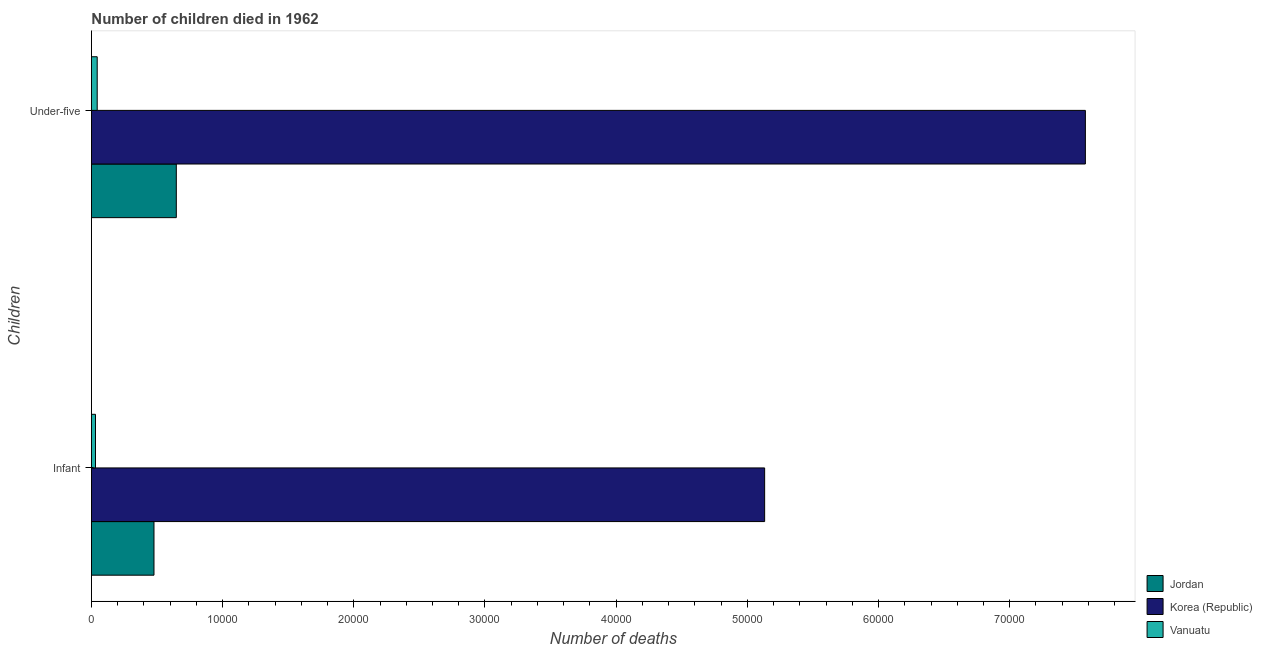Are the number of bars on each tick of the Y-axis equal?
Your answer should be very brief. Yes. How many bars are there on the 1st tick from the top?
Your response must be concise. 3. How many bars are there on the 2nd tick from the bottom?
Your answer should be very brief. 3. What is the label of the 2nd group of bars from the top?
Provide a succinct answer. Infant. What is the number of under-five deaths in Vanuatu?
Provide a succinct answer. 441. Across all countries, what is the maximum number of under-five deaths?
Give a very brief answer. 7.58e+04. Across all countries, what is the minimum number of infant deaths?
Provide a short and direct response. 311. In which country was the number of infant deaths minimum?
Keep it short and to the point. Vanuatu. What is the total number of infant deaths in the graph?
Provide a short and direct response. 5.64e+04. What is the difference between the number of infant deaths in Vanuatu and that in Korea (Republic)?
Give a very brief answer. -5.10e+04. What is the difference between the number of under-five deaths in Jordan and the number of infant deaths in Vanuatu?
Your response must be concise. 6160. What is the average number of infant deaths per country?
Make the answer very short. 1.88e+04. What is the difference between the number of infant deaths and number of under-five deaths in Jordan?
Provide a short and direct response. -1702. In how many countries, is the number of infant deaths greater than 68000 ?
Keep it short and to the point. 0. What is the ratio of the number of infant deaths in Jordan to that in Korea (Republic)?
Make the answer very short. 0.09. What does the 1st bar from the top in Under-five represents?
Keep it short and to the point. Vanuatu. What does the 1st bar from the bottom in Infant represents?
Provide a short and direct response. Jordan. Are all the bars in the graph horizontal?
Provide a succinct answer. Yes. Are the values on the major ticks of X-axis written in scientific E-notation?
Your answer should be compact. No. Does the graph contain any zero values?
Provide a succinct answer. No. Does the graph contain grids?
Your answer should be compact. No. Where does the legend appear in the graph?
Provide a succinct answer. Bottom right. How are the legend labels stacked?
Offer a very short reply. Vertical. What is the title of the graph?
Offer a terse response. Number of children died in 1962. What is the label or title of the X-axis?
Offer a very short reply. Number of deaths. What is the label or title of the Y-axis?
Provide a succinct answer. Children. What is the Number of deaths in Jordan in Infant?
Provide a short and direct response. 4769. What is the Number of deaths of Korea (Republic) in Infant?
Provide a short and direct response. 5.13e+04. What is the Number of deaths of Vanuatu in Infant?
Ensure brevity in your answer.  311. What is the Number of deaths in Jordan in Under-five?
Ensure brevity in your answer.  6471. What is the Number of deaths in Korea (Republic) in Under-five?
Your answer should be compact. 7.58e+04. What is the Number of deaths in Vanuatu in Under-five?
Give a very brief answer. 441. Across all Children, what is the maximum Number of deaths in Jordan?
Ensure brevity in your answer.  6471. Across all Children, what is the maximum Number of deaths of Korea (Republic)?
Provide a short and direct response. 7.58e+04. Across all Children, what is the maximum Number of deaths of Vanuatu?
Make the answer very short. 441. Across all Children, what is the minimum Number of deaths of Jordan?
Keep it short and to the point. 4769. Across all Children, what is the minimum Number of deaths in Korea (Republic)?
Your response must be concise. 5.13e+04. Across all Children, what is the minimum Number of deaths of Vanuatu?
Provide a short and direct response. 311. What is the total Number of deaths in Jordan in the graph?
Your answer should be very brief. 1.12e+04. What is the total Number of deaths in Korea (Republic) in the graph?
Offer a very short reply. 1.27e+05. What is the total Number of deaths of Vanuatu in the graph?
Provide a succinct answer. 752. What is the difference between the Number of deaths in Jordan in Infant and that in Under-five?
Provide a short and direct response. -1702. What is the difference between the Number of deaths of Korea (Republic) in Infant and that in Under-five?
Your answer should be very brief. -2.44e+04. What is the difference between the Number of deaths of Vanuatu in Infant and that in Under-five?
Your answer should be very brief. -130. What is the difference between the Number of deaths in Jordan in Infant and the Number of deaths in Korea (Republic) in Under-five?
Your answer should be very brief. -7.10e+04. What is the difference between the Number of deaths of Jordan in Infant and the Number of deaths of Vanuatu in Under-five?
Make the answer very short. 4328. What is the difference between the Number of deaths of Korea (Republic) in Infant and the Number of deaths of Vanuatu in Under-five?
Keep it short and to the point. 5.09e+04. What is the average Number of deaths of Jordan per Children?
Your response must be concise. 5620. What is the average Number of deaths of Korea (Republic) per Children?
Offer a terse response. 6.35e+04. What is the average Number of deaths of Vanuatu per Children?
Provide a succinct answer. 376. What is the difference between the Number of deaths in Jordan and Number of deaths in Korea (Republic) in Infant?
Your answer should be compact. -4.66e+04. What is the difference between the Number of deaths of Jordan and Number of deaths of Vanuatu in Infant?
Your answer should be compact. 4458. What is the difference between the Number of deaths in Korea (Republic) and Number of deaths in Vanuatu in Infant?
Your response must be concise. 5.10e+04. What is the difference between the Number of deaths of Jordan and Number of deaths of Korea (Republic) in Under-five?
Make the answer very short. -6.93e+04. What is the difference between the Number of deaths in Jordan and Number of deaths in Vanuatu in Under-five?
Your answer should be very brief. 6030. What is the difference between the Number of deaths in Korea (Republic) and Number of deaths in Vanuatu in Under-five?
Offer a very short reply. 7.53e+04. What is the ratio of the Number of deaths in Jordan in Infant to that in Under-five?
Your response must be concise. 0.74. What is the ratio of the Number of deaths in Korea (Republic) in Infant to that in Under-five?
Your answer should be very brief. 0.68. What is the ratio of the Number of deaths in Vanuatu in Infant to that in Under-five?
Your response must be concise. 0.71. What is the difference between the highest and the second highest Number of deaths of Jordan?
Your answer should be very brief. 1702. What is the difference between the highest and the second highest Number of deaths of Korea (Republic)?
Keep it short and to the point. 2.44e+04. What is the difference between the highest and the second highest Number of deaths in Vanuatu?
Offer a very short reply. 130. What is the difference between the highest and the lowest Number of deaths of Jordan?
Make the answer very short. 1702. What is the difference between the highest and the lowest Number of deaths of Korea (Republic)?
Make the answer very short. 2.44e+04. What is the difference between the highest and the lowest Number of deaths in Vanuatu?
Provide a short and direct response. 130. 